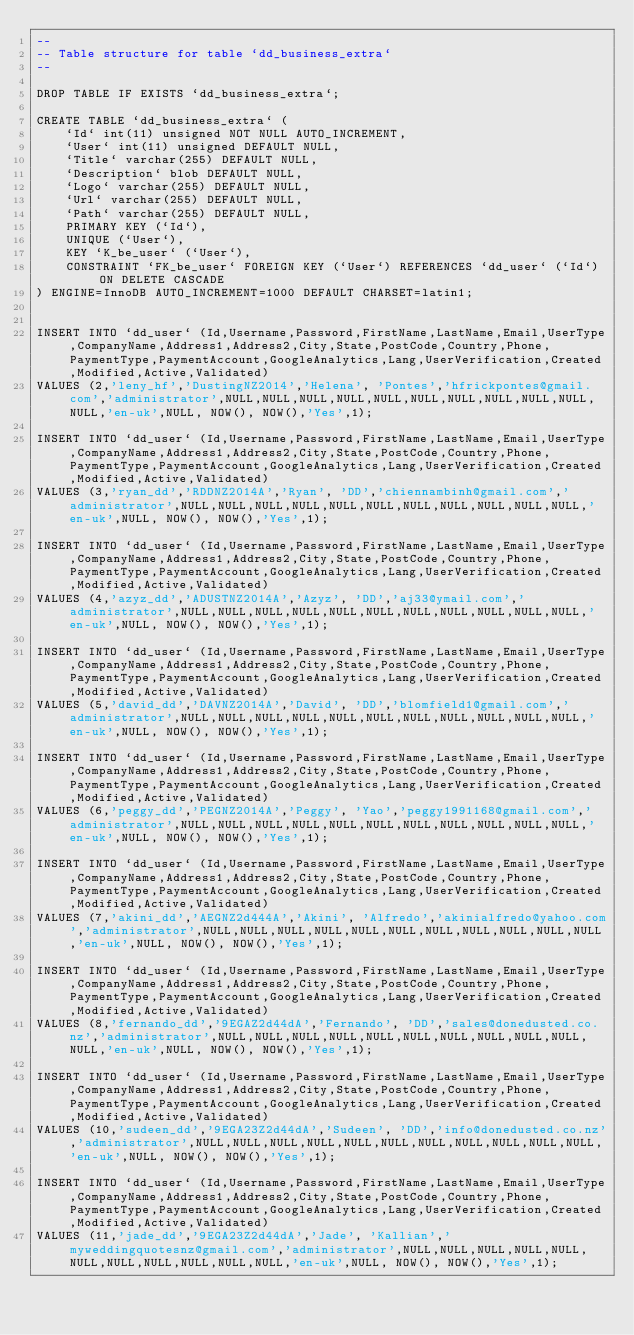<code> <loc_0><loc_0><loc_500><loc_500><_SQL_>--
-- Table structure for table `dd_business_extra`
--

DROP TABLE IF EXISTS `dd_business_extra`;

CREATE TABLE `dd_business_extra` (
    `Id` int(11) unsigned NOT NULL AUTO_INCREMENT,
    `User` int(11) unsigned DEFAULT NULL,
    `Title` varchar(255) DEFAULT NULL,
    `Description` blob DEFAULT NULL,
    `Logo` varchar(255) DEFAULT NULL,
    `Url` varchar(255) DEFAULT NULL,
    `Path` varchar(255) DEFAULT NULL,
    PRIMARY KEY (`Id`),
    UNIQUE (`User`),
    KEY `K_be_user` (`User`),
    CONSTRAINT `FK_be_user` FOREIGN KEY (`User`) REFERENCES `dd_user` (`Id`) ON DELETE CASCADE
) ENGINE=InnoDB AUTO_INCREMENT=1000 DEFAULT CHARSET=latin1;


INSERT INTO `dd_user` (Id,Username,Password,FirstName,LastName,Email,UserType,CompanyName,Address1,Address2,City,State,PostCode,Country,Phone,PaymentType,PaymentAccount,GoogleAnalytics,Lang,UserVerification,Created,Modified,Active,Validated)
VALUES (2,'leny_hf','DustingNZ2014','Helena', 'Pontes','hfrickpontes@gmail.com','administrator',NULL,NULL,NULL,NULL,NULL,NULL,NULL,NULL,NULL,NULL,NULL,'en-uk',NULL, NOW(), NOW(),'Yes',1);

INSERT INTO `dd_user` (Id,Username,Password,FirstName,LastName,Email,UserType,CompanyName,Address1,Address2,City,State,PostCode,Country,Phone,PaymentType,PaymentAccount,GoogleAnalytics,Lang,UserVerification,Created,Modified,Active,Validated)
VALUES (3,'ryan_dd','RDDNZ2014A','Ryan', 'DD','chiennambinh@gmail.com','administrator',NULL,NULL,NULL,NULL,NULL,NULL,NULL,NULL,NULL,NULL,NULL,'en-uk',NULL, NOW(), NOW(),'Yes',1);

INSERT INTO `dd_user` (Id,Username,Password,FirstName,LastName,Email,UserType,CompanyName,Address1,Address2,City,State,PostCode,Country,Phone,PaymentType,PaymentAccount,GoogleAnalytics,Lang,UserVerification,Created,Modified,Active,Validated)
VALUES (4,'azyz_dd','ADUSTNZ2014A','Azyz', 'DD','aj33@ymail.com','administrator',NULL,NULL,NULL,NULL,NULL,NULL,NULL,NULL,NULL,NULL,NULL,'en-uk',NULL, NOW(), NOW(),'Yes',1);

INSERT INTO `dd_user` (Id,Username,Password,FirstName,LastName,Email,UserType,CompanyName,Address1,Address2,City,State,PostCode,Country,Phone,PaymentType,PaymentAccount,GoogleAnalytics,Lang,UserVerification,Created,Modified,Active,Validated)
VALUES (5,'david_dd','DAVNZ2014A','David', 'DD','blomfield1@gmail.com','administrator',NULL,NULL,NULL,NULL,NULL,NULL,NULL,NULL,NULL,NULL,NULL,'en-uk',NULL, NOW(), NOW(),'Yes',1);

INSERT INTO `dd_user` (Id,Username,Password,FirstName,LastName,Email,UserType,CompanyName,Address1,Address2,City,State,PostCode,Country,Phone,PaymentType,PaymentAccount,GoogleAnalytics,Lang,UserVerification,Created,Modified,Active,Validated)
VALUES (6,'peggy_dd','PEGNZ2014A','Peggy', 'Yao','peggy1991168@gmail.com','administrator',NULL,NULL,NULL,NULL,NULL,NULL,NULL,NULL,NULL,NULL,NULL,'en-uk',NULL, NOW(), NOW(),'Yes',1);

INSERT INTO `dd_user` (Id,Username,Password,FirstName,LastName,Email,UserType,CompanyName,Address1,Address2,City,State,PostCode,Country,Phone,PaymentType,PaymentAccount,GoogleAnalytics,Lang,UserVerification,Created,Modified,Active,Validated)
VALUES (7,'akini_dd','AEGNZ2d444A','Akini', 'Alfredo','akinialfredo@yahoo.com','administrator',NULL,NULL,NULL,NULL,NULL,NULL,NULL,NULL,NULL,NULL,NULL,'en-uk',NULL, NOW(), NOW(),'Yes',1);

INSERT INTO `dd_user` (Id,Username,Password,FirstName,LastName,Email,UserType,CompanyName,Address1,Address2,City,State,PostCode,Country,Phone,PaymentType,PaymentAccount,GoogleAnalytics,Lang,UserVerification,Created,Modified,Active,Validated)
VALUES (8,'fernando_dd','9EGAZ2d44dA','Fernando', 'DD','sales@donedusted.co.nz','administrator',NULL,NULL,NULL,NULL,NULL,NULL,NULL,NULL,NULL,NULL,NULL,'en-uk',NULL, NOW(), NOW(),'Yes',1);

INSERT INTO `dd_user` (Id,Username,Password,FirstName,LastName,Email,UserType,CompanyName,Address1,Address2,City,State,PostCode,Country,Phone,PaymentType,PaymentAccount,GoogleAnalytics,Lang,UserVerification,Created,Modified,Active,Validated)
VALUES (10,'sudeen_dd','9EGA23Z2d44dA','Sudeen', 'DD','info@donedusted.co.nz','administrator',NULL,NULL,NULL,NULL,NULL,NULL,NULL,NULL,NULL,NULL,NULL,'en-uk',NULL, NOW(), NOW(),'Yes',1);

INSERT INTO `dd_user` (Id,Username,Password,FirstName,LastName,Email,UserType,CompanyName,Address1,Address2,City,State,PostCode,Country,Phone,PaymentType,PaymentAccount,GoogleAnalytics,Lang,UserVerification,Created,Modified,Active,Validated)
VALUES (11,'jade_dd','9EGA23Z2d44dA','Jade', 'Kallian','myweddingquotesnz@gmail.com','administrator',NULL,NULL,NULL,NULL,NULL,NULL,NULL,NULL,NULL,NULL,NULL,'en-uk',NULL, NOW(), NOW(),'Yes',1);</code> 